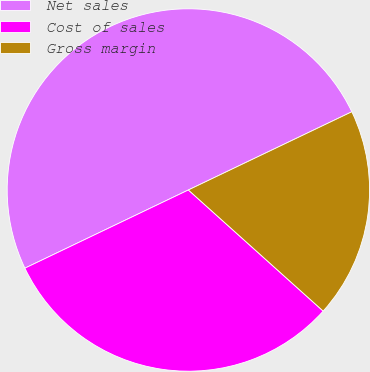Convert chart to OTSL. <chart><loc_0><loc_0><loc_500><loc_500><pie_chart><fcel>Net sales<fcel>Cost of sales<fcel>Gross margin<nl><fcel>50.0%<fcel>31.25%<fcel>18.75%<nl></chart> 